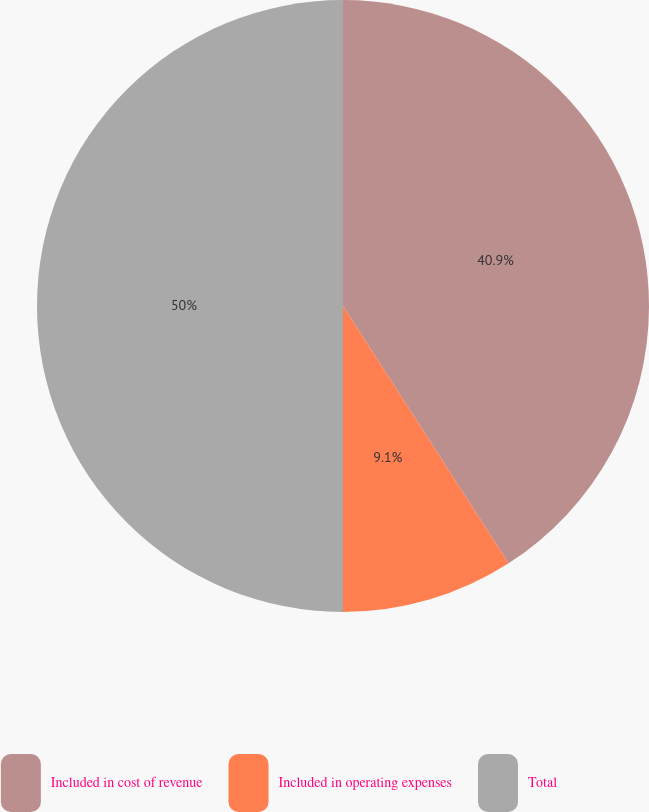Convert chart. <chart><loc_0><loc_0><loc_500><loc_500><pie_chart><fcel>Included in cost of revenue<fcel>Included in operating expenses<fcel>Total<nl><fcel>40.9%<fcel>9.1%<fcel>50.0%<nl></chart> 